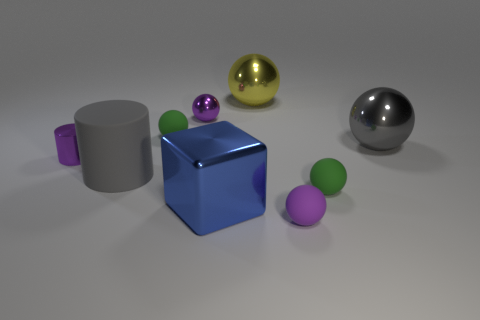Add 1 small cyan matte balls. How many objects exist? 10 Subtract all small purple balls. How many balls are left? 4 Subtract all cylinders. How many objects are left? 7 Add 6 tiny shiny cylinders. How many tiny shiny cylinders are left? 7 Add 2 yellow things. How many yellow things exist? 3 Subtract all gray balls. How many balls are left? 5 Subtract 0 yellow blocks. How many objects are left? 9 Subtract 1 spheres. How many spheres are left? 5 Subtract all cyan cubes. Subtract all cyan balls. How many cubes are left? 1 Subtract all gray spheres. How many yellow cylinders are left? 0 